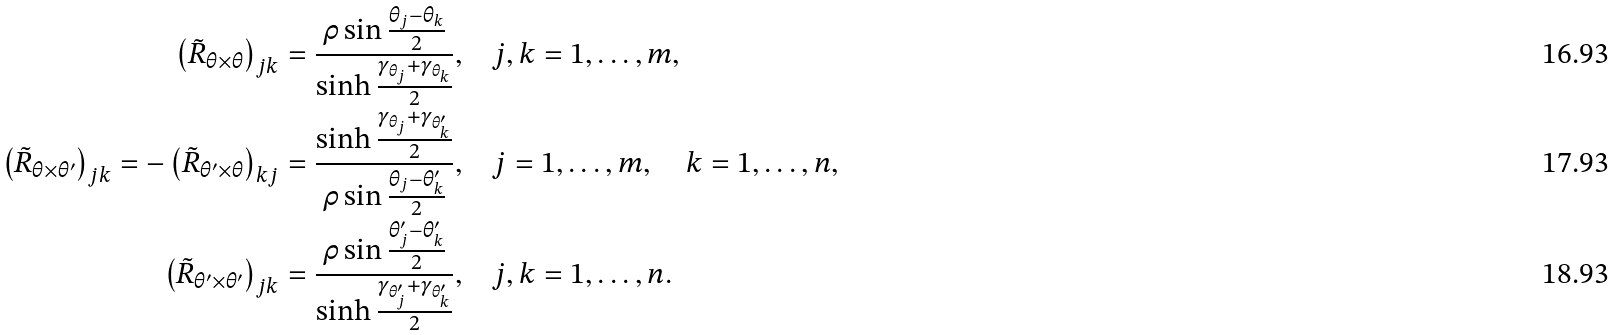Convert formula to latex. <formula><loc_0><loc_0><loc_500><loc_500>\left ( \tilde { R } _ { \theta \times \theta } \right ) _ { j k } = \frac { \rho \sin \frac { \theta _ { j } - \theta _ { k } } { 2 } } { \sinh \frac { \gamma _ { \theta _ { j } } + \gamma _ { \theta _ { k } } } { 2 } } , & \quad j , k = 1 , \dots , m , \\ \left ( \tilde { R } _ { \theta \times \theta ^ { \prime } } \right ) _ { j k } = - \left ( \tilde { R } _ { \theta ^ { \prime } \times \theta } \right ) _ { k j } = \frac { \sinh \frac { \gamma _ { \theta _ { j } } + \gamma _ { \theta ^ { \prime } _ { k } } } { 2 } } { \rho \sin \frac { \theta _ { j } - \theta ^ { \prime } _ { k } } { 2 } } , & \quad j = 1 , \dots , m , \quad k = 1 , \dots , n , \\ \left ( \tilde { R } _ { \theta ^ { \prime } \times \theta ^ { \prime } } \right ) _ { j k } = \frac { \rho \sin \frac { \theta ^ { \prime } _ { j } - \theta ^ { \prime } _ { k } } { 2 } } { \sinh \frac { \gamma _ { \theta ^ { \prime } _ { j } } + \gamma _ { \theta ^ { \prime } _ { k } } } { 2 } } , & \quad j , k = 1 , \dots , n .</formula> 